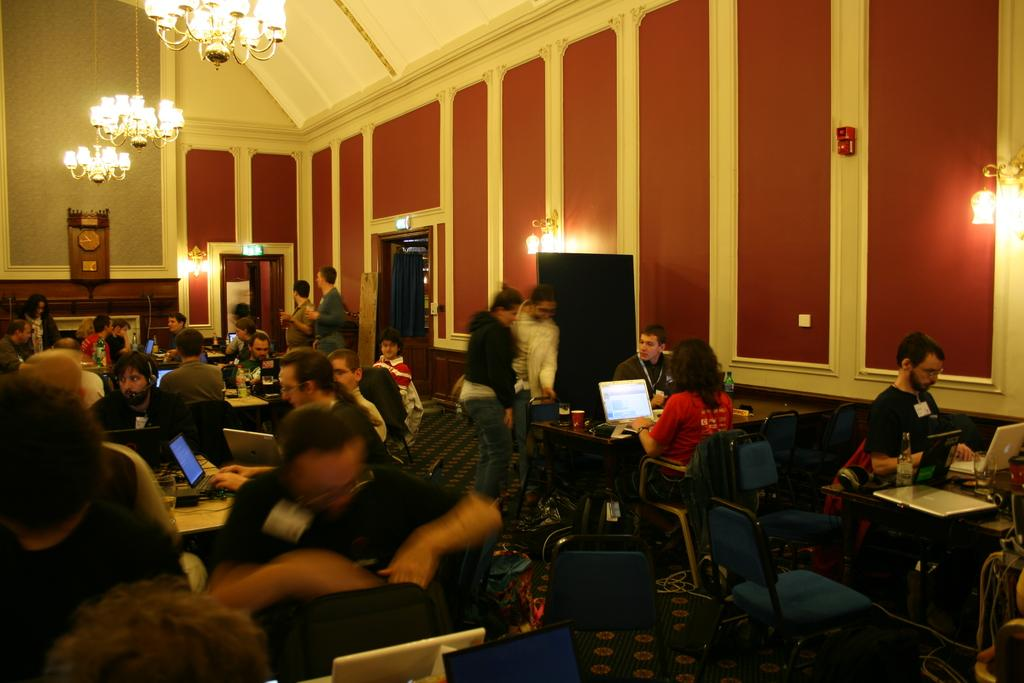What are the people in the image doing? The people in the image are sitting. What are the people sitting on? The people are sitting on chairs. What else can be seen in the image besides the people and chairs? There are tables, laptops, lights, a wall, and a clock visible in the image. What type of bait is being used to catch the fish in the image? There is no mention of fish or bait in the image; it features people sitting on chairs with laptops and other objects. 